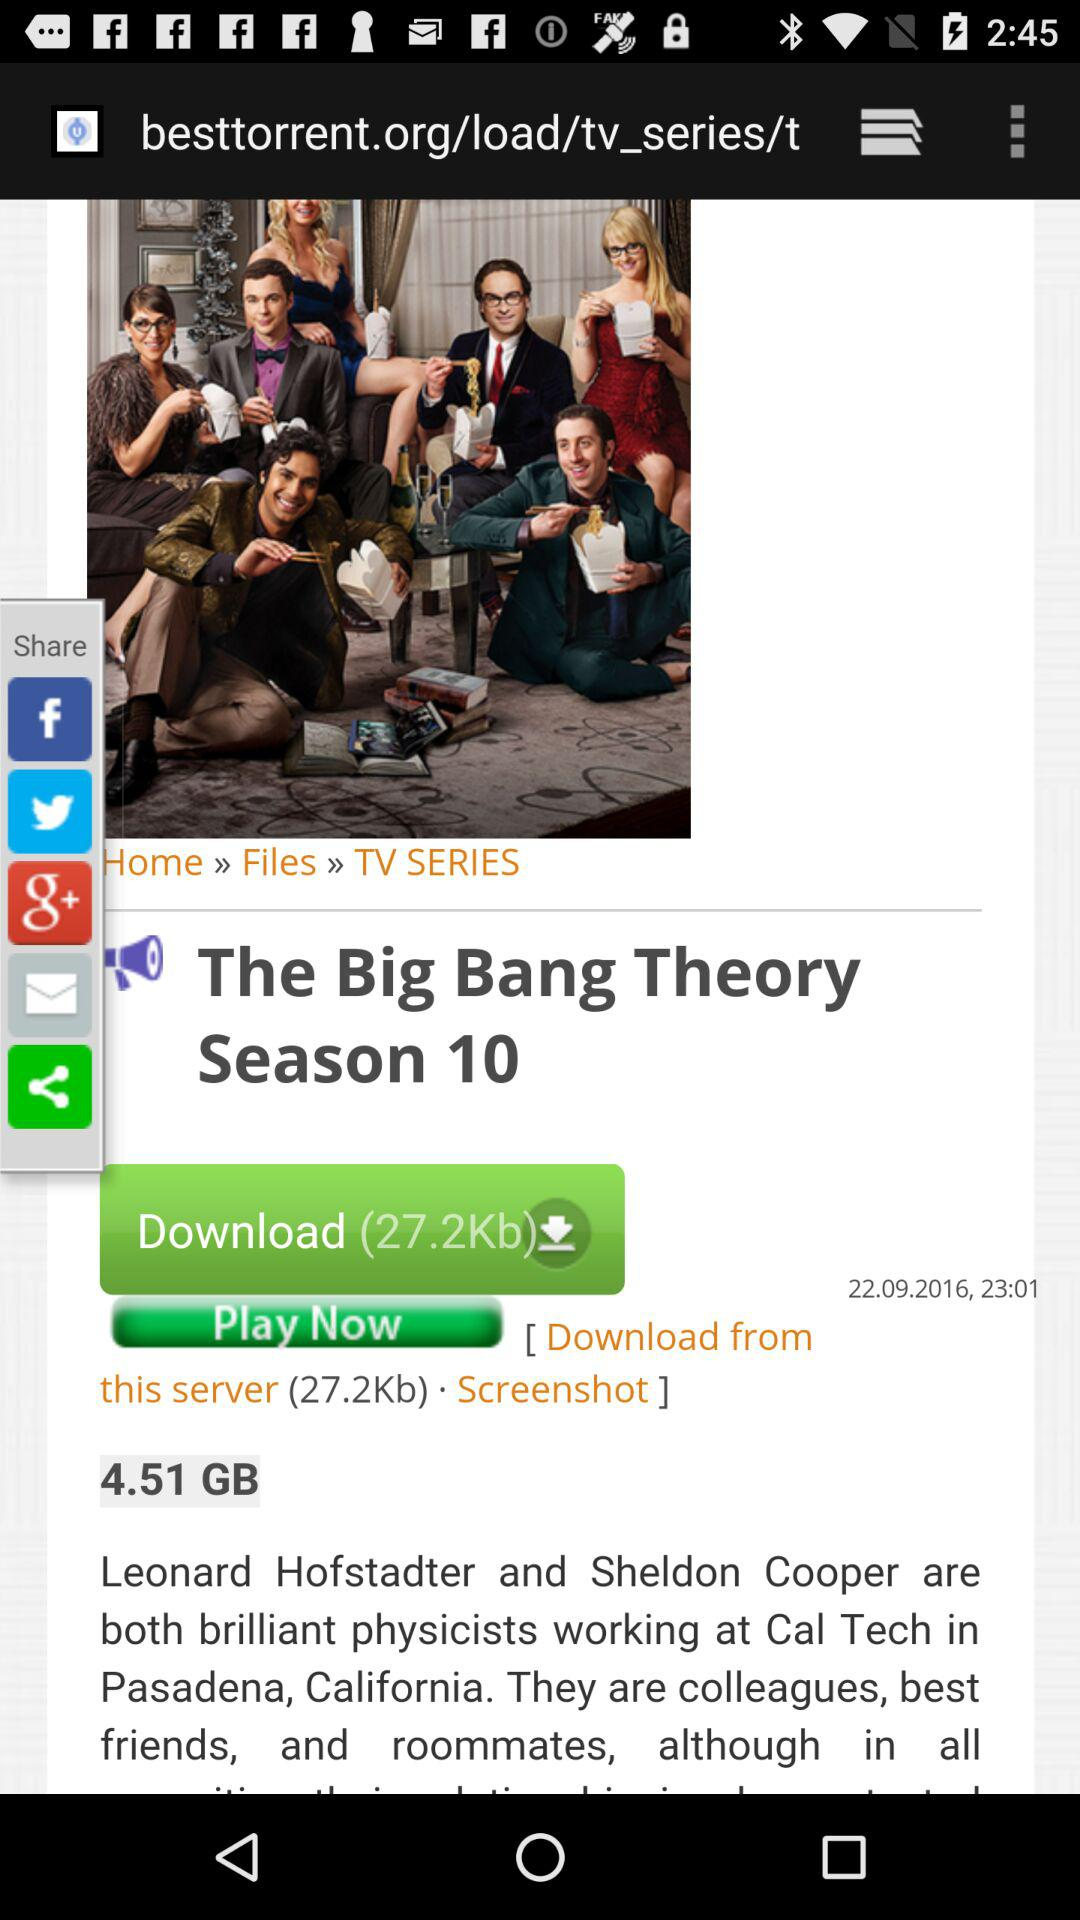What is the post date of "The Big Bang Theory Season 10"? The post date of "The Big Bang Theory Season 10" is September 22, 2016. 